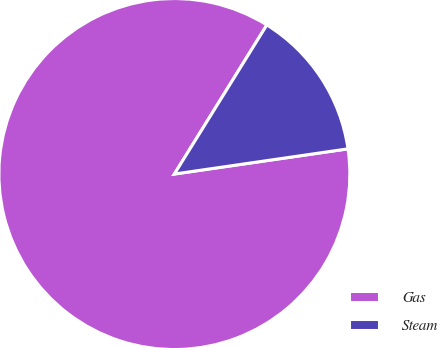<chart> <loc_0><loc_0><loc_500><loc_500><pie_chart><fcel>Gas<fcel>Steam<nl><fcel>86.13%<fcel>13.87%<nl></chart> 